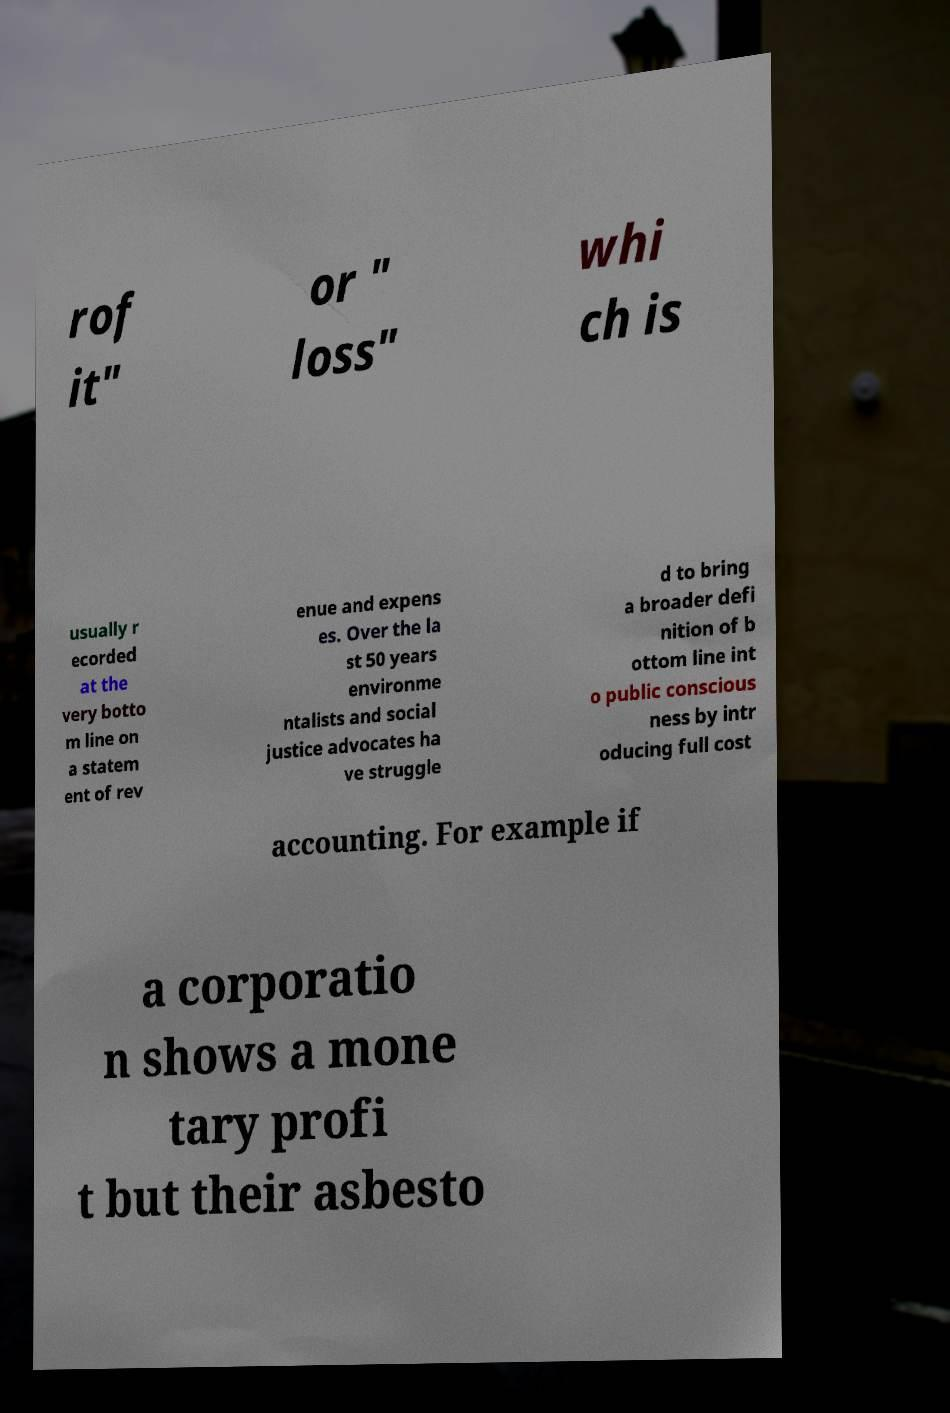Please read and relay the text visible in this image. What does it say? rof it" or " loss" whi ch is usually r ecorded at the very botto m line on a statem ent of rev enue and expens es. Over the la st 50 years environme ntalists and social justice advocates ha ve struggle d to bring a broader defi nition of b ottom line int o public conscious ness by intr oducing full cost accounting. For example if a corporatio n shows a mone tary profi t but their asbesto 